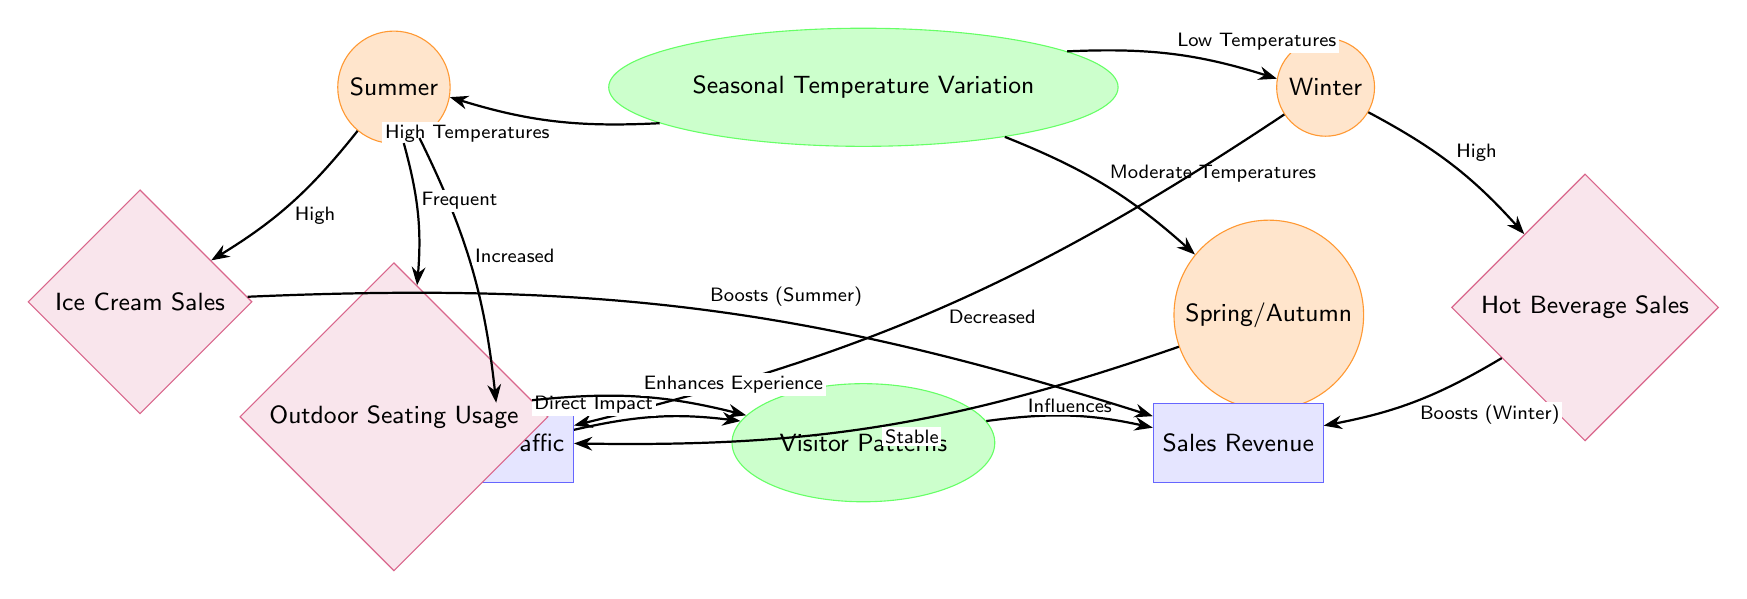What are the three seasons represented in the diagram? The diagram shows three seasons: Summer, Winter, and Spring/Autumn. These seasons are clearly labeled as nodes connected to the main node "Seasonal Temperature Variation."
Answer: Summer, Winter, Spring/Autumn What kind of sales is boosted in summer? The diagram indicates that Ice Cream Sales are boosted in the summer, as shown by the connection from the Summer node to the Ice Cream Sales effect node.
Answer: Ice Cream Sales What happens to foot traffic in winter? According to the diagram, foot traffic is labeled as "Decreased" in the winter, as indicated by the arrow from the Winter node to the Traffic factor node.
Answer: Decreased Which season correlates with high hot beverage sales? The diagram indicates that high hot beverage sales are associated specifically with winter, as shown by the connection from the Winter node to the Hot Beverage Sales effect node.
Answer: Winter How does summer temperature affect outdoor seating usage? The diagram shows that during summer, the outdoor seating usage is described as "Frequent," indicating a positive relationship between high temperatures in summer and outdoor seating utilization.
Answer: Frequent What is the relationship between traffic and visitor patterns? The diagram states that traffic has a "Direct Impact" on visitor patterns, as depicted by the arrow connecting the Traffic factor node to the Visitor Patterns node.
Answer: Direct Impact What seasonal temperature variation is linked to stable traffic? The moderate temperatures experienced in Spring/Autumn are described as "Stable," leading to stable foot traffic, as indicated by the connection from the Spring node to the Traffic factor node.
Answer: Stable Which factor influences sales revenue? The Visitor Patterns node influences sales revenue, as shown by the arrow from the Visitor Patterns node to the Sales Revenue factor node in the diagram.
Answer: Influences What effect does outdoor seating have on visitor patterns? The diagram describes outdoor seating usage as having a "Enhances Experience" effect on visitor patterns, showing a connection between these two elements.
Answer: Enhances Experience 